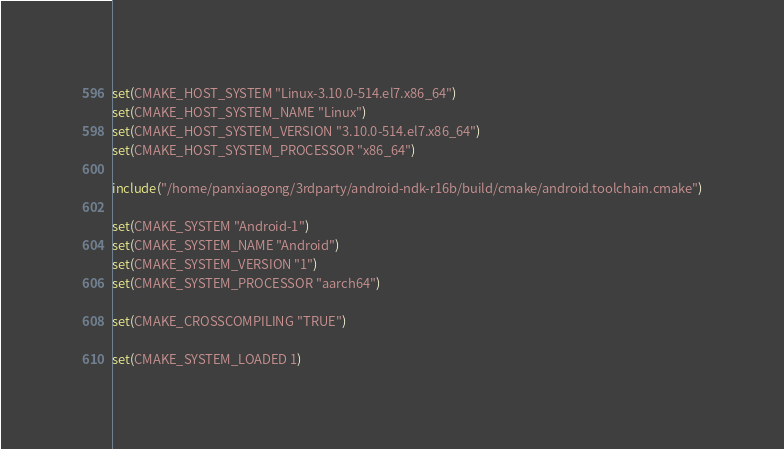Convert code to text. <code><loc_0><loc_0><loc_500><loc_500><_CMake_>set(CMAKE_HOST_SYSTEM "Linux-3.10.0-514.el7.x86_64")
set(CMAKE_HOST_SYSTEM_NAME "Linux")
set(CMAKE_HOST_SYSTEM_VERSION "3.10.0-514.el7.x86_64")
set(CMAKE_HOST_SYSTEM_PROCESSOR "x86_64")

include("/home/panxiaogong/3rdparty/android-ndk-r16b/build/cmake/android.toolchain.cmake")

set(CMAKE_SYSTEM "Android-1")
set(CMAKE_SYSTEM_NAME "Android")
set(CMAKE_SYSTEM_VERSION "1")
set(CMAKE_SYSTEM_PROCESSOR "aarch64")

set(CMAKE_CROSSCOMPILING "TRUE")

set(CMAKE_SYSTEM_LOADED 1)
</code> 